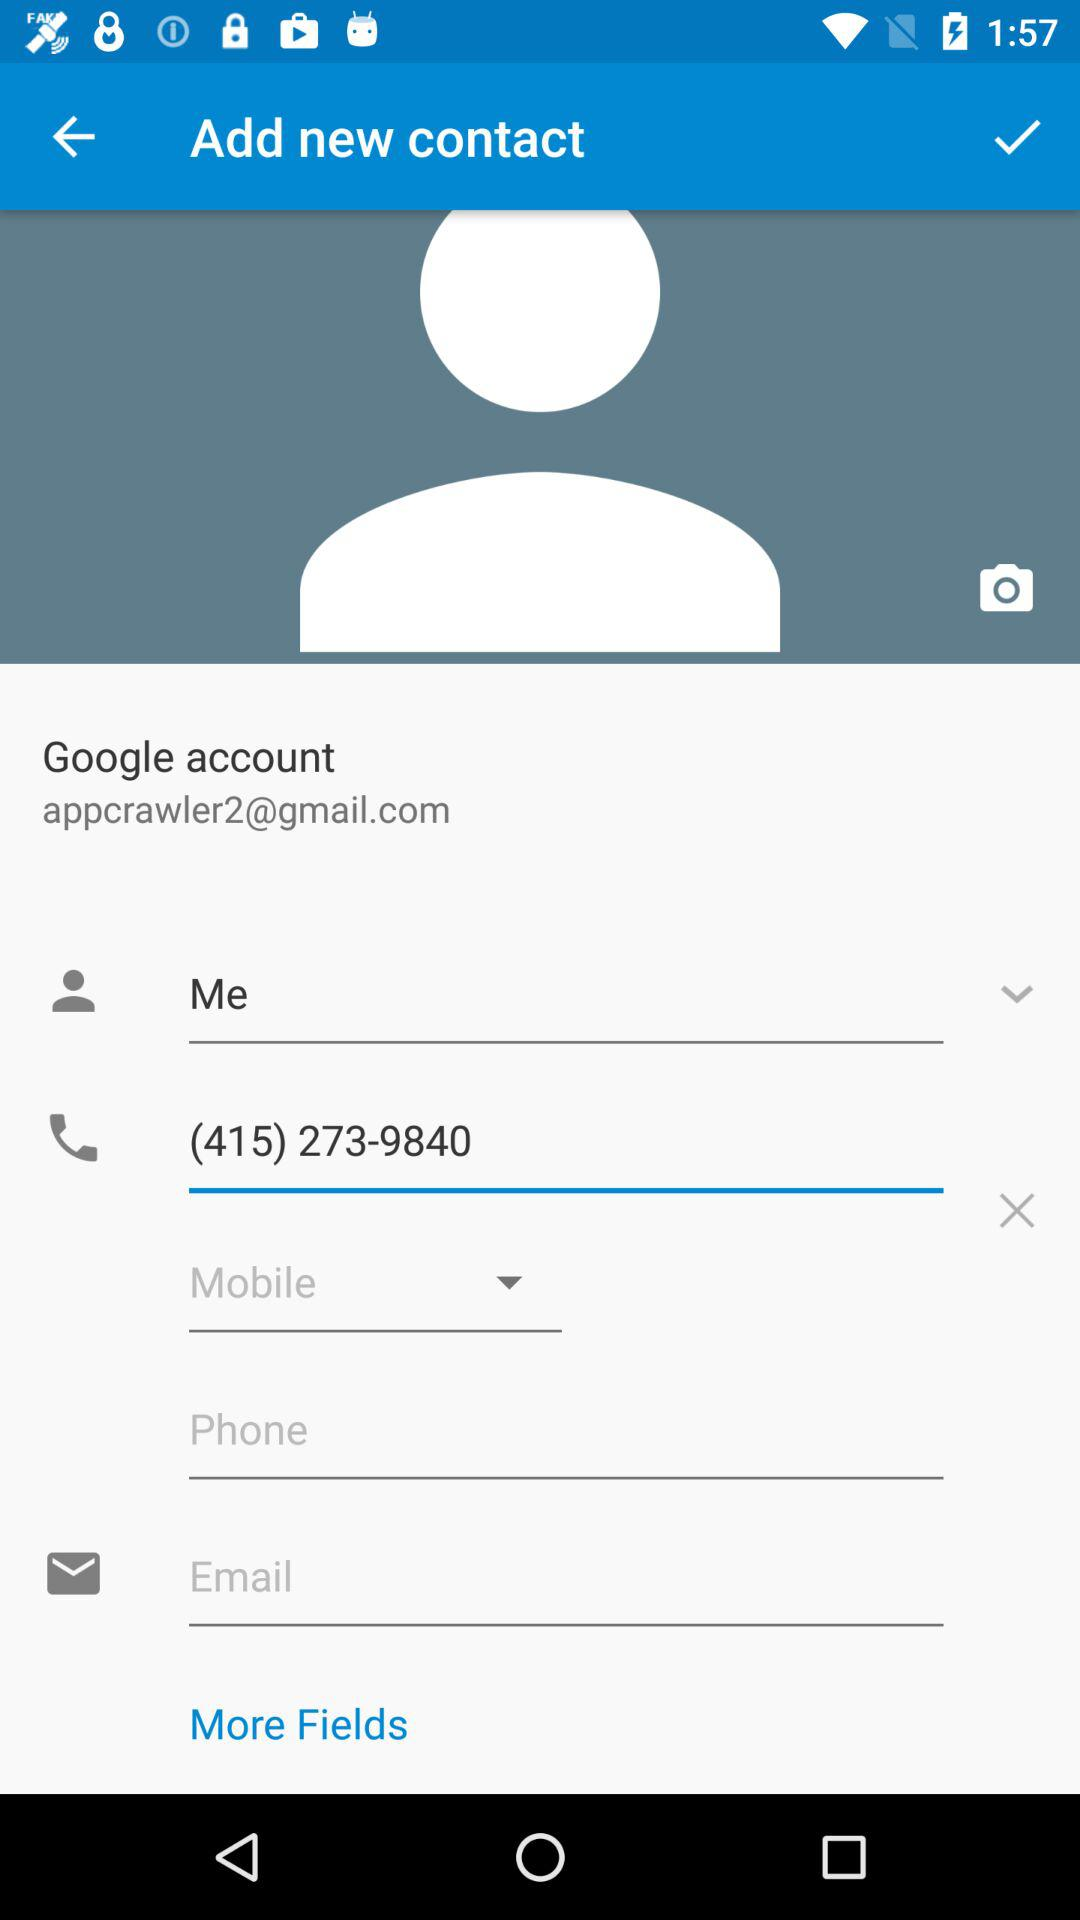What is the given email address for the Google account? The given email address is "appcrawler2@gmail.com". 